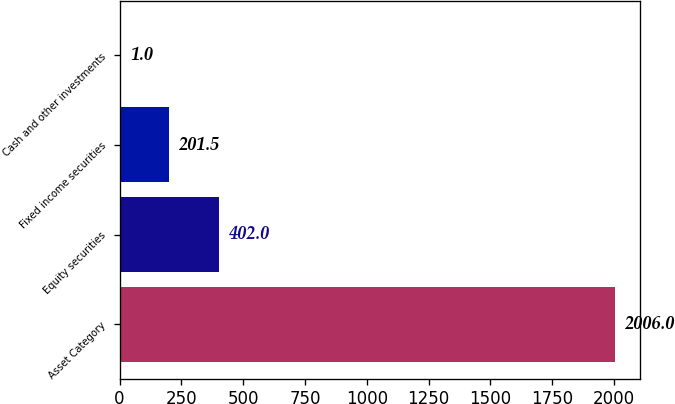Convert chart to OTSL. <chart><loc_0><loc_0><loc_500><loc_500><bar_chart><fcel>Asset Category<fcel>Equity securities<fcel>Fixed income securities<fcel>Cash and other investments<nl><fcel>2006<fcel>402<fcel>201.5<fcel>1<nl></chart> 